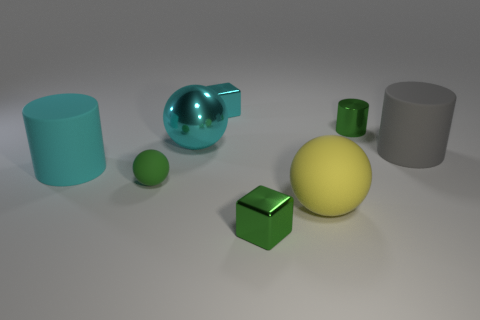Add 2 metallic spheres. How many objects exist? 10 Subtract all cylinders. How many objects are left? 5 Add 8 small green metallic cubes. How many small green metallic cubes are left? 9 Add 6 large metallic balls. How many large metallic balls exist? 7 Subtract 0 purple balls. How many objects are left? 8 Subtract all green cylinders. Subtract all big yellow things. How many objects are left? 6 